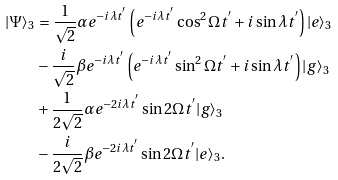Convert formula to latex. <formula><loc_0><loc_0><loc_500><loc_500>| \Psi \rangle _ { 3 } & = \frac { 1 } { \sqrt { 2 } } \alpha e ^ { - i \lambda t ^ { ^ { \prime } } } \left ( e ^ { - i \lambda t ^ { ^ { \prime } } } \cos ^ { 2 } \Omega t ^ { ^ { \prime } } + i \sin \lambda t ^ { ^ { \prime } } \right ) | e \rangle _ { 3 } \\ & - \frac { i } { \sqrt { 2 } } \beta e ^ { - i \lambda t ^ { ^ { \prime } } } \left ( e ^ { - i \lambda t ^ { ^ { \prime } } } \sin ^ { 2 } \Omega t ^ { ^ { \prime } } + i \sin \lambda t ^ { ^ { \prime } } \right ) | g \rangle _ { 3 } \\ & + \frac { 1 } { 2 \sqrt { 2 } } \alpha e ^ { - 2 i \lambda t ^ { ^ { \prime } } } \sin 2 \Omega t ^ { ^ { \prime } } | g \rangle _ { 3 } \\ & - \frac { i } { 2 \sqrt { 2 } } \beta e ^ { - 2 i \lambda t ^ { ^ { \prime } } } \sin 2 \Omega t ^ { ^ { \prime } } | e \rangle _ { 3 } .</formula> 